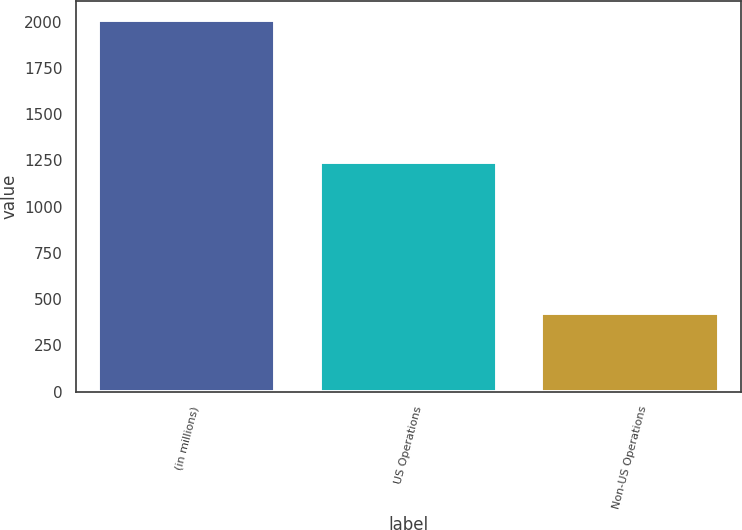Convert chart to OTSL. <chart><loc_0><loc_0><loc_500><loc_500><bar_chart><fcel>(in millions)<fcel>US Operations<fcel>Non-US Operations<nl><fcel>2009<fcel>1240.8<fcel>426.2<nl></chart> 